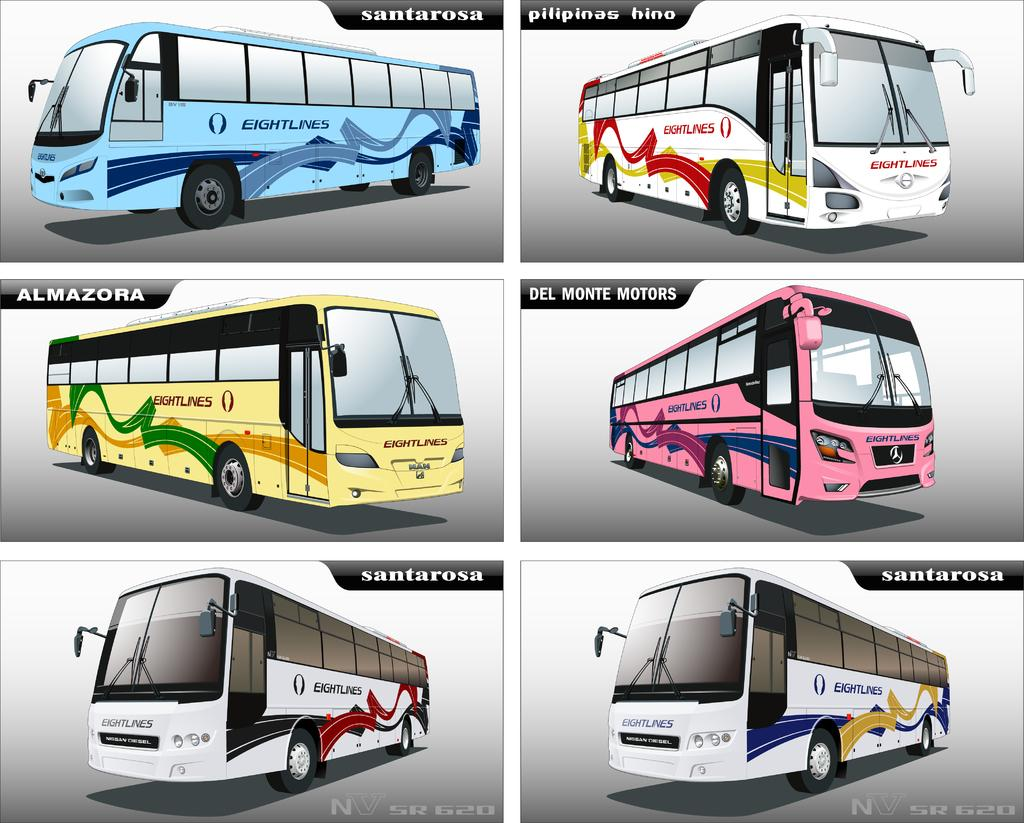How many buses can be seen on the road in the image? There are six buses on the road in the image. What else is present in the image besides the buses? There is a text in the image. Can you tell if the image has been altered or edited? Yes, the image appears to be an edited photo. How many cherries are on top of the buses in the image? There are no cherries present in the image; it features buses on a road. What type of point is being made in the text in the image? The text in the image does not convey a point or message that can be determined from the image alone. 